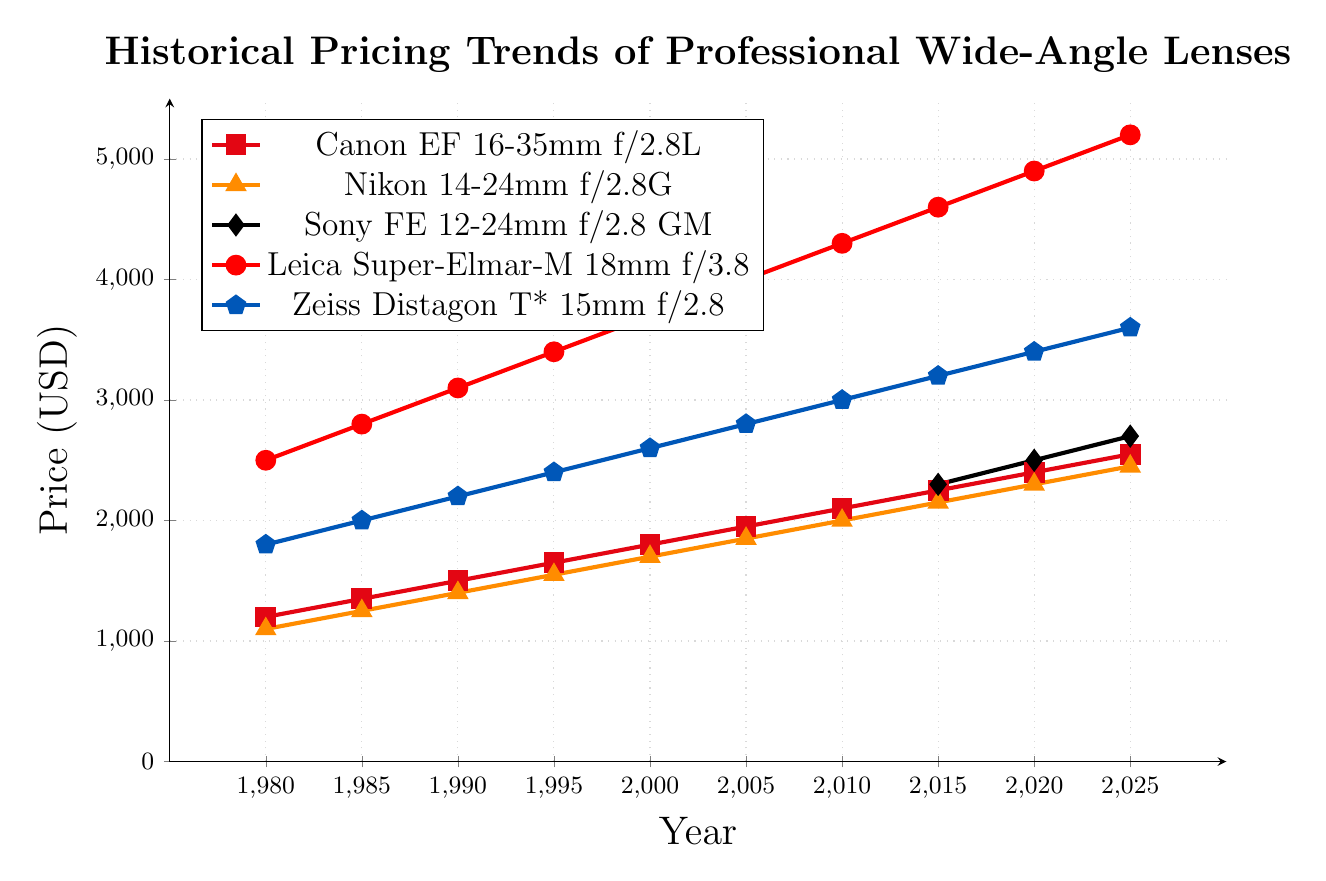Which lens had the highest initial price in 1980? To find the highest initial price in 1980, we look at the prices of all lenses for that year. The prices are: Canon - 1200, Nikon - 1100, Sony - N/A, Leica - 2500, Zeiss - 1800. Leica's price of 2500 is the highest.
Answer: Leica Super-Elmar-M 18mm f/3.8 What was the approximate average price of all lenses in 1990? In 1990, we have the following lens prices: Canon - 1500, Nikon - 1400, Leica - 3100, Zeiss - 2200. Sony is not available in 1990. Summing these up: 1500 + 1400 + 3100 + 2200 = 8200. Dividing by the number of available lens prices (4): 8200 / 4 = 2050.
Answer: 2050 Between Canon and Nikon lenses, which had a higher price in 2000 and by how much? In 2000, the prices are: Canon - 1800, Nikon - 1700. The difference is 1800 - 1700 = 100.
Answer: Canon by 100 Comparing the trendlines, which lens shows the steepest increase in price from 1980 to 2025? To determine which lens shows the steepest increase, we compare the initial and final prices: Canon (1200 to 2550), Nikon (1100 to 2450), Leica (2500 to 5200), Zeiss (1800 to 3600). Calculating the price increases: Canon - 1350, Nikon - 1350, Leica - 2700, Zeiss - 1800. Leica has the steepest increase at 2700.
Answer: Leica Super-Elmar-M 18mm f/3.8 What is the price difference between Sony and Zeiss lenses in 2025? In 2025, the prices are: Sony - 2700, Zeiss - 3600. The difference is 3600 - 2700 = 900.
Answer: 900 Which lens shows the largest price increase between any two consecutive data points? By examining all the lens price changes each 5 years: Canon varies by 150, Nikon by 150, Sony by 200, Leica by 300, and Zeiss by 200. Leica's increase from 1985 to 1990 is 3100 - 2800 = 300. This is the largest single-period increase.
Answer: Leica Super-Elmar-M 18mm f/3.8 On average, how much did the price of Canon lenses increase every five years? The price of Canon lenses from 1980 to 2025 increases by steps of 150 (i.e., 1350 - 1200), across 9 intervals: (1200 to 1350), (1350 to 1500), (1500 to 1650), (1650 to 1800), (1800 to 1950), (1950 to 2100), (2100 to 2250), (2250 to 2400), (2400 to 2550). Each interval is 5 years, so the average increase is simply the calculated step: 150.
Answer: 150 How did the availability of Sony lenses change the average price of lenses in 2015? In 2015, before including Sony: average of Canon (2250), Nikon (2150), Leica (4600), Zeiss (3200) = (2250 + 2150 + 4600 + 3200) / 4 = 3050. After including Sony (2300): (2250 + 2150 + 4600 + 3200 + 2300) / 5 = 2900. The average decreased with Sony's inclusion: 3050 - 2900 = 150.
Answer: Decreased by 150 